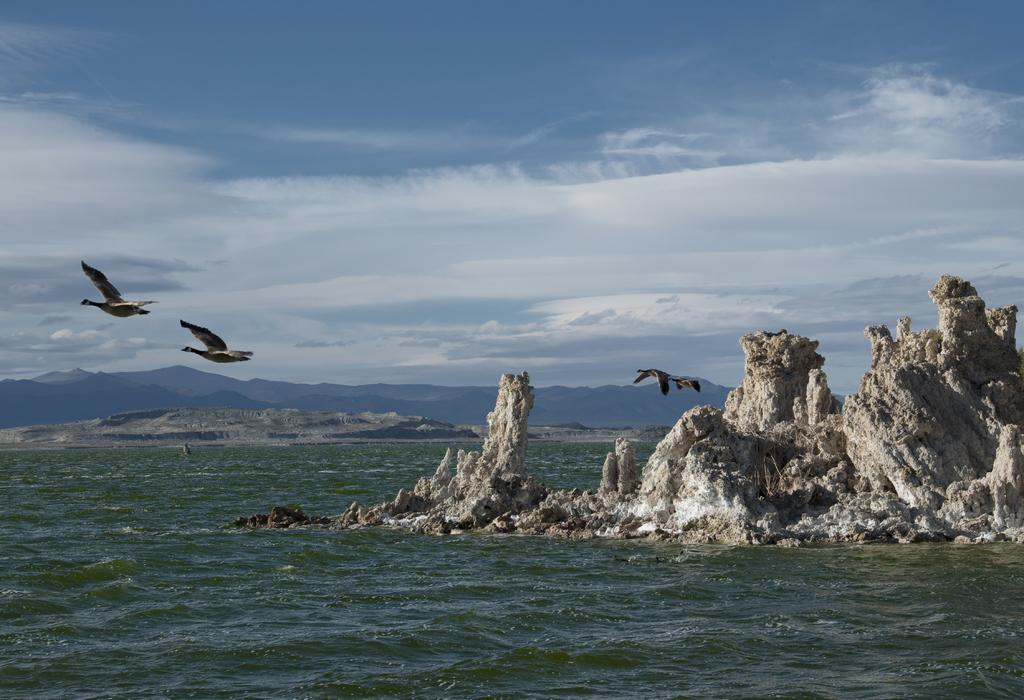What type of animals can be seen in the image? There are birds in the image. What is located at the bottom of the image? There is water at the bottom of the image. What type of natural features can be seen in the image? There are visible in the image. A: There are rocks visible in the image. What can be seen in the background of the image? There are hills and the sky visible in the background of the image. What type of scarf is being worn by the snails in the image? There are no snails or scarves present in the image. What type of ground can be seen in the image? The ground is not explicitly mentioned in the provided facts, but it can be inferred that there is a combination of water, rocks, and possibly grass or soil in the image. 